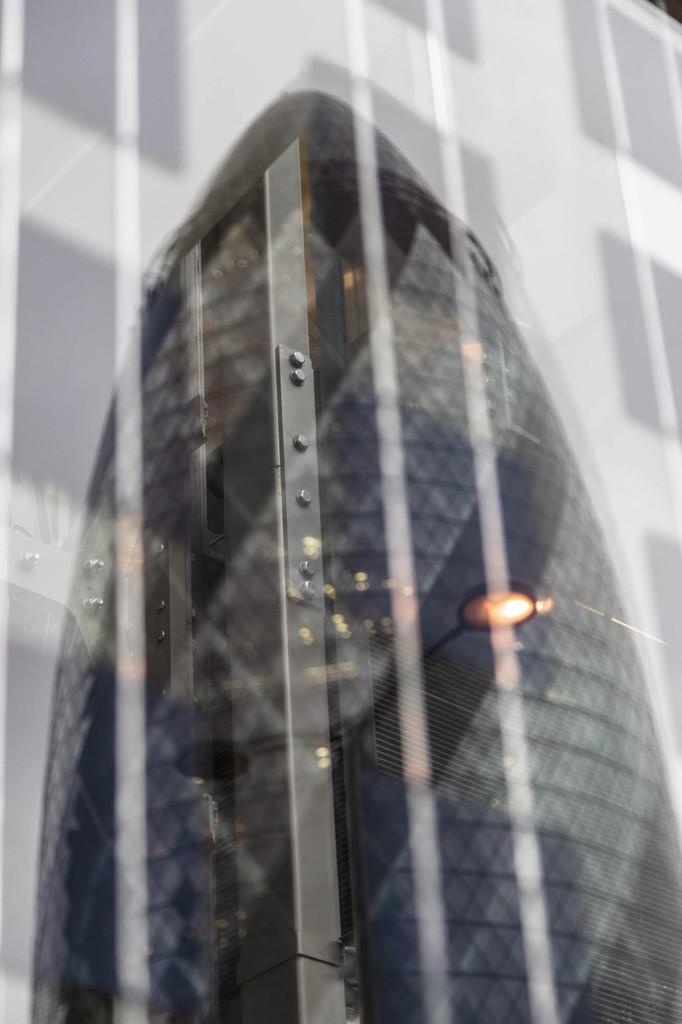Could you give a brief overview of what you see in this image? In image there is a glass material having reflection of a tower, behind it there is a building. 